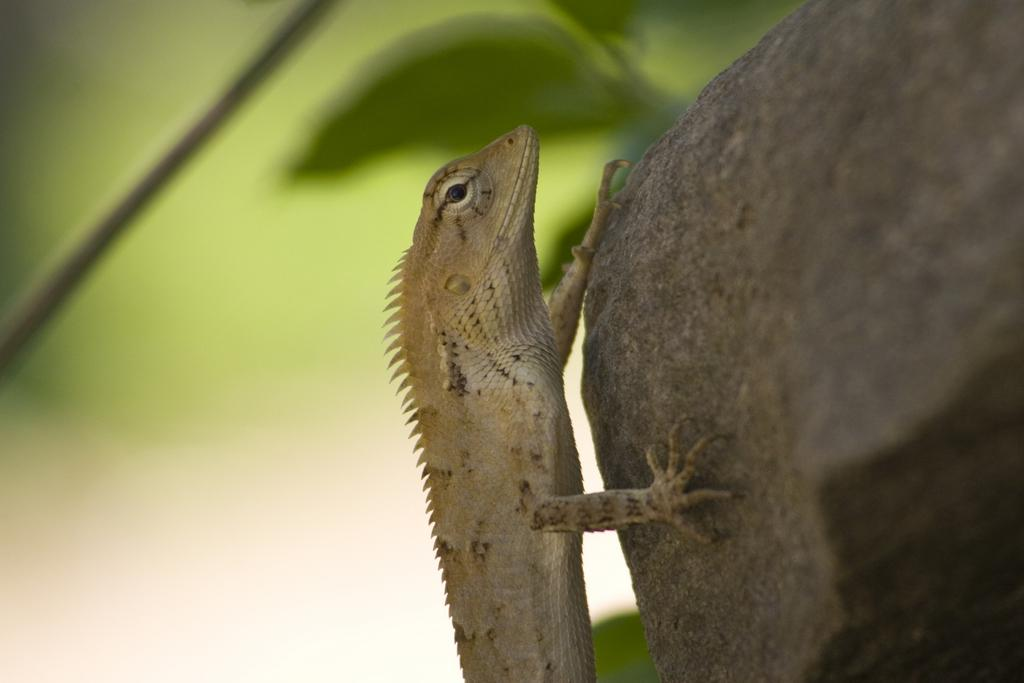What object is located on the right side of the image? There is a stone on the right side of the image. What is on top of the stone? A lizard is present on the stone. What can be seen in the background of the image? There are leaves visible in the background of the image. How would you describe the overall clarity of the image? The image appears to be slightly blurry. Can you see a man holding a goldfish in the image? There is no man or goldfish present in the image. 